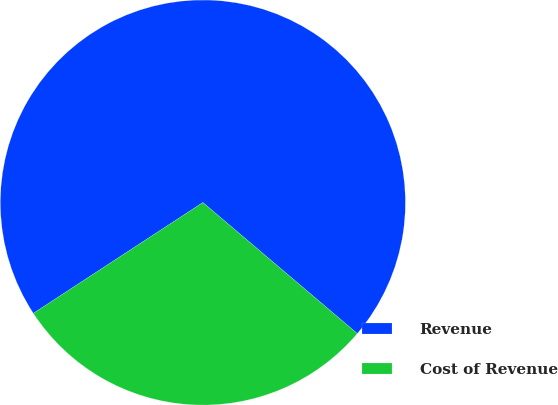Convert chart to OTSL. <chart><loc_0><loc_0><loc_500><loc_500><pie_chart><fcel>Revenue<fcel>Cost of Revenue<nl><fcel>70.41%<fcel>29.59%<nl></chart> 